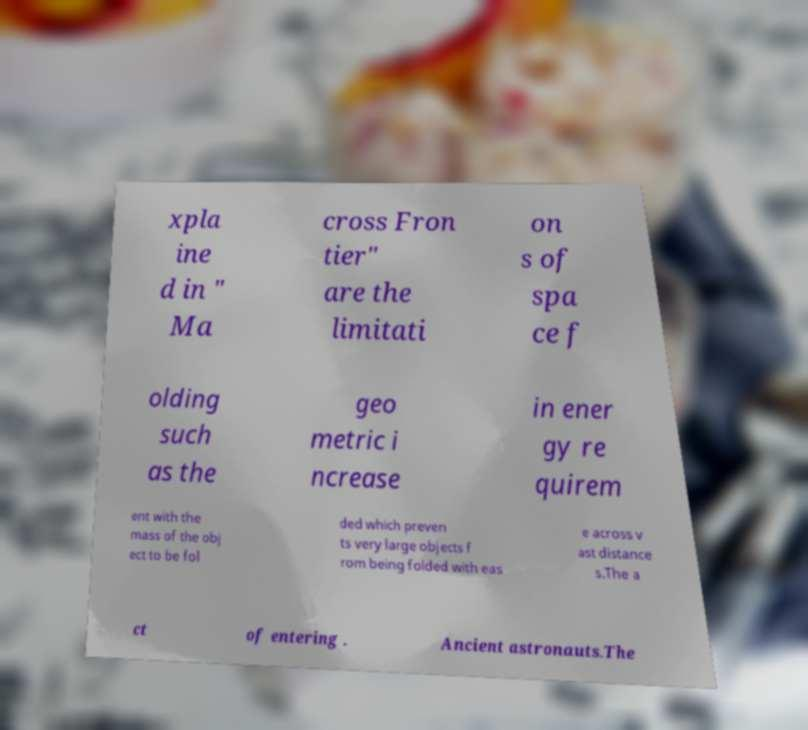Can you accurately transcribe the text from the provided image for me? xpla ine d in " Ma cross Fron tier" are the limitati on s of spa ce f olding such as the geo metric i ncrease in ener gy re quirem ent with the mass of the obj ect to be fol ded which preven ts very large objects f rom being folded with eas e across v ast distance s.The a ct of entering . Ancient astronauts.The 